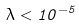<formula> <loc_0><loc_0><loc_500><loc_500>\lambda < 1 0 ^ { - 5 }</formula> 